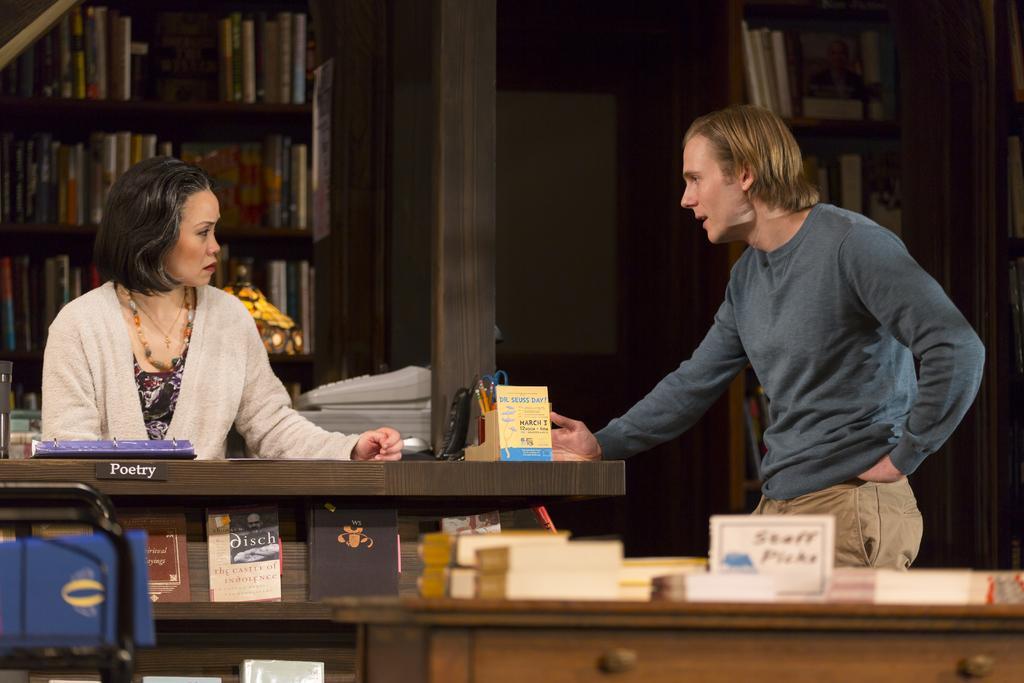Can you describe this image briefly? In this picture we can see a man and a woman here, in the background we can see rack, there are some books on the rack, we can see a table here, there are some books here, we can see a board here. 